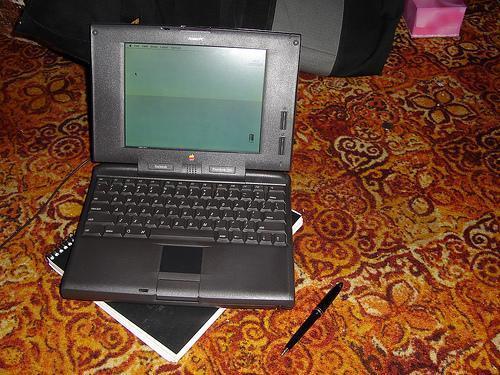How many notebooks are in the picture?
Give a very brief answer. 1. How many spacebars are on the laptop?
Give a very brief answer. 1. 